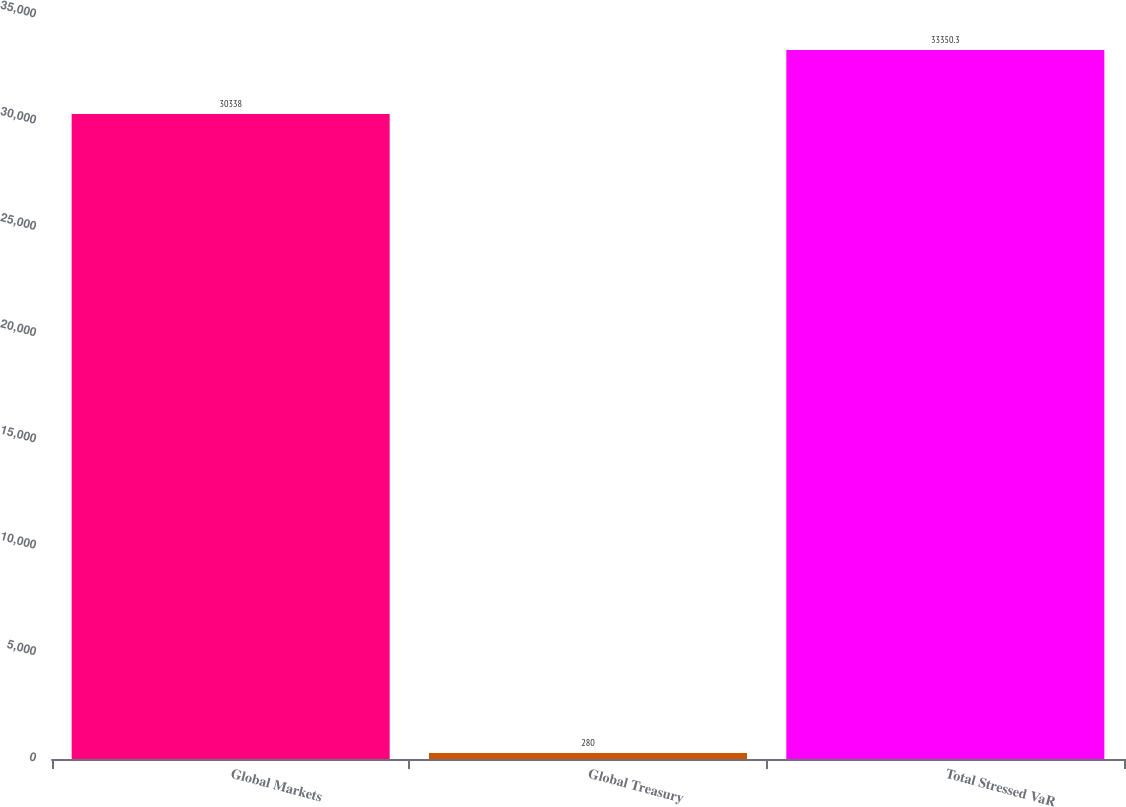Convert chart to OTSL. <chart><loc_0><loc_0><loc_500><loc_500><bar_chart><fcel>Global Markets<fcel>Global Treasury<fcel>Total Stressed VaR<nl><fcel>30338<fcel>280<fcel>33350.3<nl></chart> 